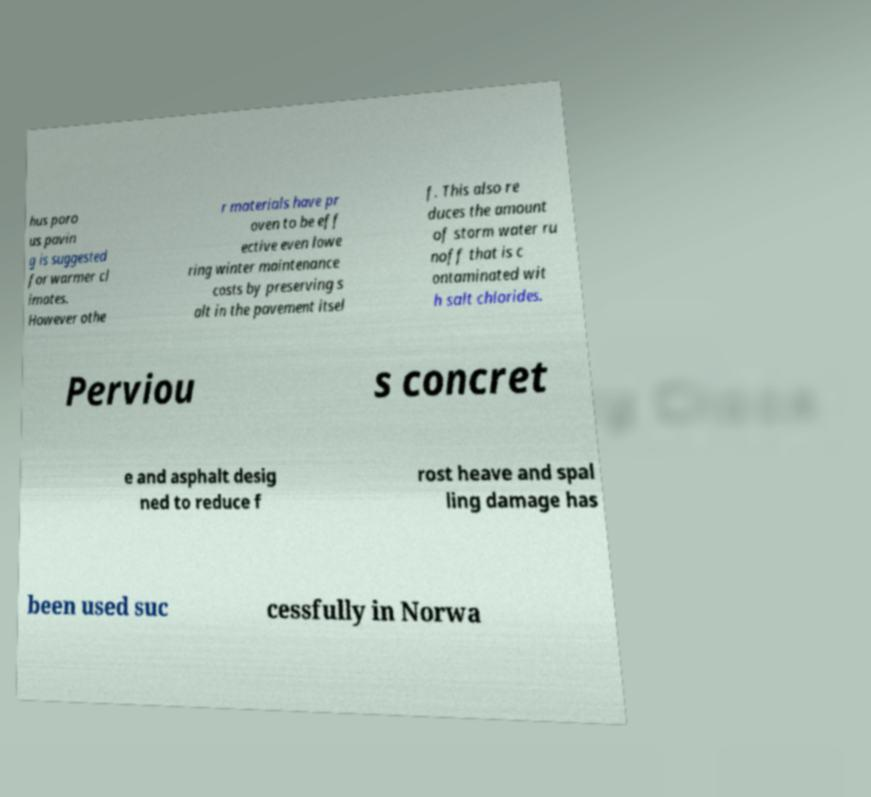Could you extract and type out the text from this image? hus poro us pavin g is suggested for warmer cl imates. However othe r materials have pr oven to be eff ective even lowe ring winter maintenance costs by preserving s alt in the pavement itsel f. This also re duces the amount of storm water ru noff that is c ontaminated wit h salt chlorides. Perviou s concret e and asphalt desig ned to reduce f rost heave and spal ling damage has been used suc cessfully in Norwa 